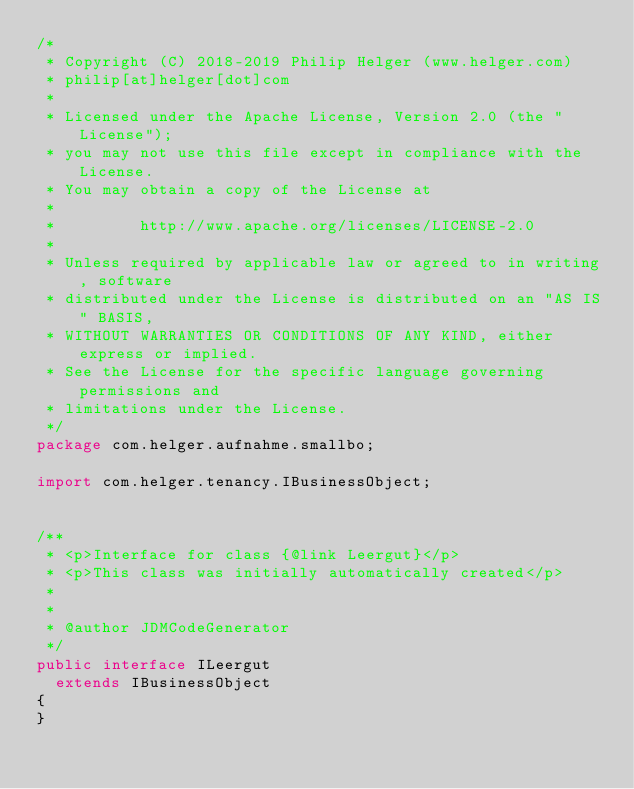Convert code to text. <code><loc_0><loc_0><loc_500><loc_500><_Java_>/*
 * Copyright (C) 2018-2019 Philip Helger (www.helger.com)
 * philip[at]helger[dot]com
 *
 * Licensed under the Apache License, Version 2.0 (the "License");
 * you may not use this file except in compliance with the License.
 * You may obtain a copy of the License at
 *
 *         http://www.apache.org/licenses/LICENSE-2.0
 *
 * Unless required by applicable law or agreed to in writing, software
 * distributed under the License is distributed on an "AS IS" BASIS,
 * WITHOUT WARRANTIES OR CONDITIONS OF ANY KIND, either express or implied.
 * See the License for the specific language governing permissions and
 * limitations under the License.
 */
package com.helger.aufnahme.smallbo;

import com.helger.tenancy.IBusinessObject;


/**
 * <p>Interface for class {@link Leergut}</p>
 * <p>This class was initially automatically created</p>
 * 
 * 
 * @author JDMCodeGenerator
 */
public interface ILeergut
  extends IBusinessObject
{
}
</code> 